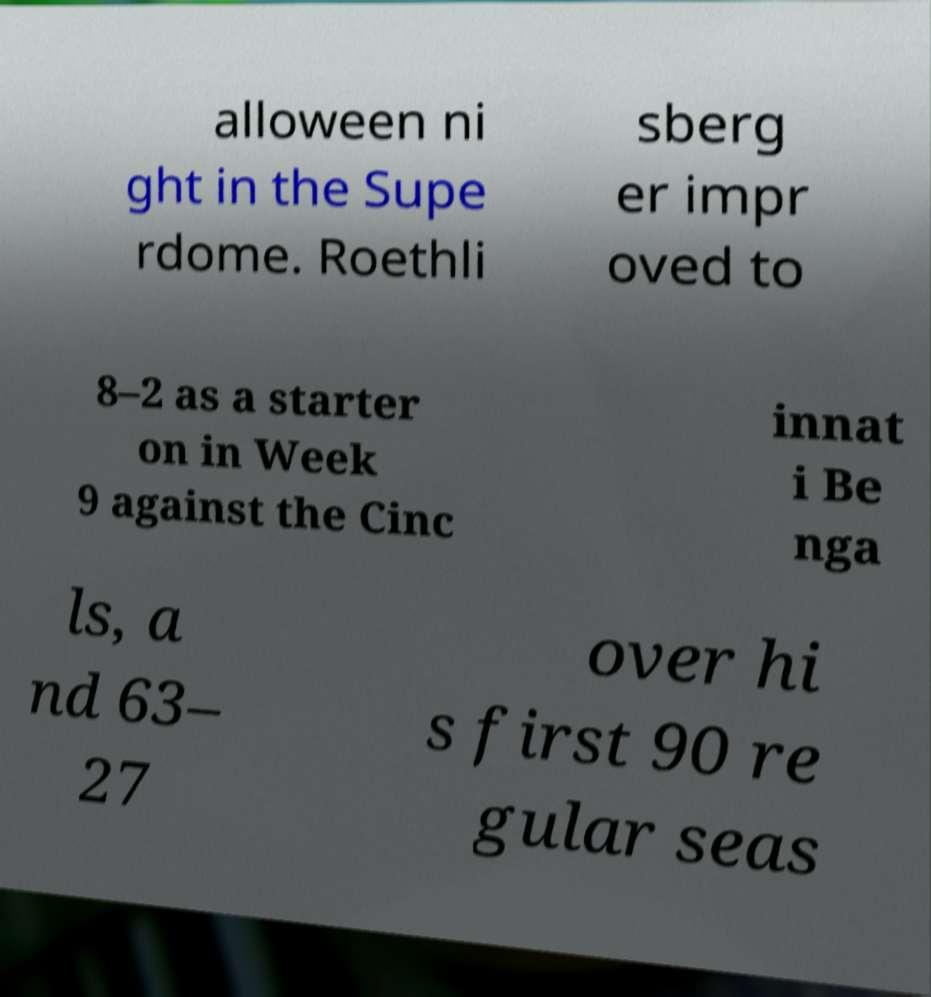What messages or text are displayed in this image? I need them in a readable, typed format. alloween ni ght in the Supe rdome. Roethli sberg er impr oved to 8–2 as a starter on in Week 9 against the Cinc innat i Be nga ls, a nd 63– 27 over hi s first 90 re gular seas 